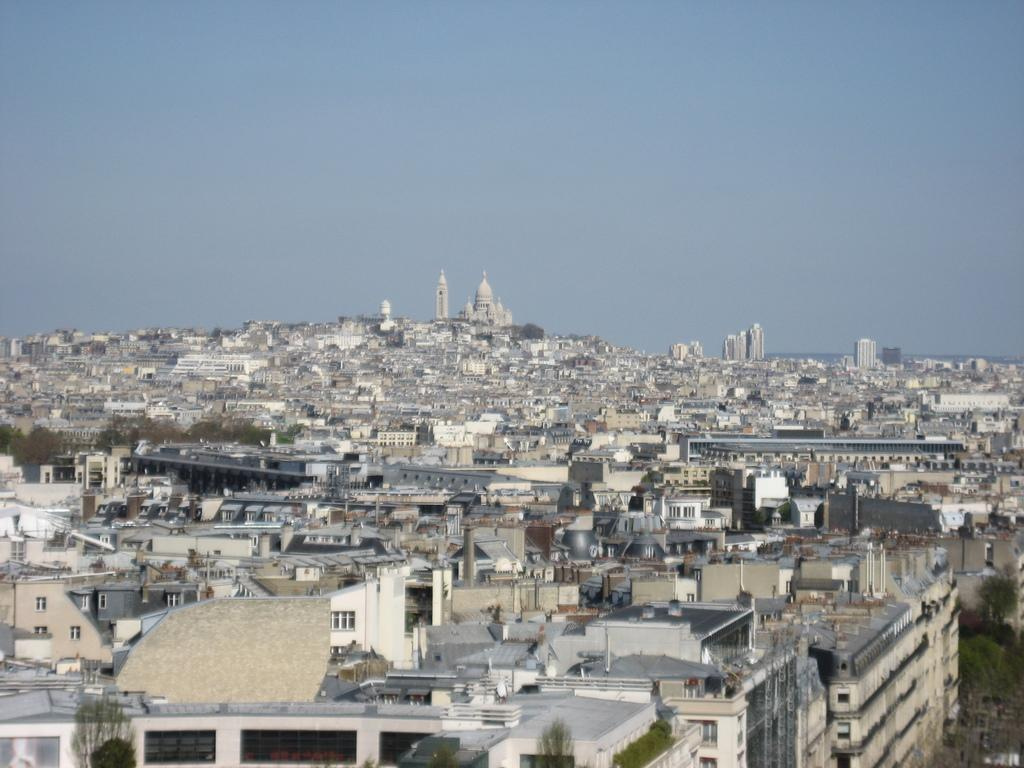What type of structures can be seen in the image? There are buildings in the image. What natural elements are present in the image? There are trees in the image. What else can be seen in the image besides buildings and trees? There are objects in the image. What is visible in the background of the image? The sky is visible in the background of the image. What type of clock is present in the image? There is no clock present in the image. What error can be seen in the image? There is no error present in the image. 